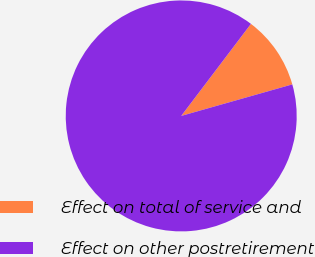Convert chart to OTSL. <chart><loc_0><loc_0><loc_500><loc_500><pie_chart><fcel>Effect on total of service and<fcel>Effect on other postretirement<nl><fcel>10.28%<fcel>89.72%<nl></chart> 